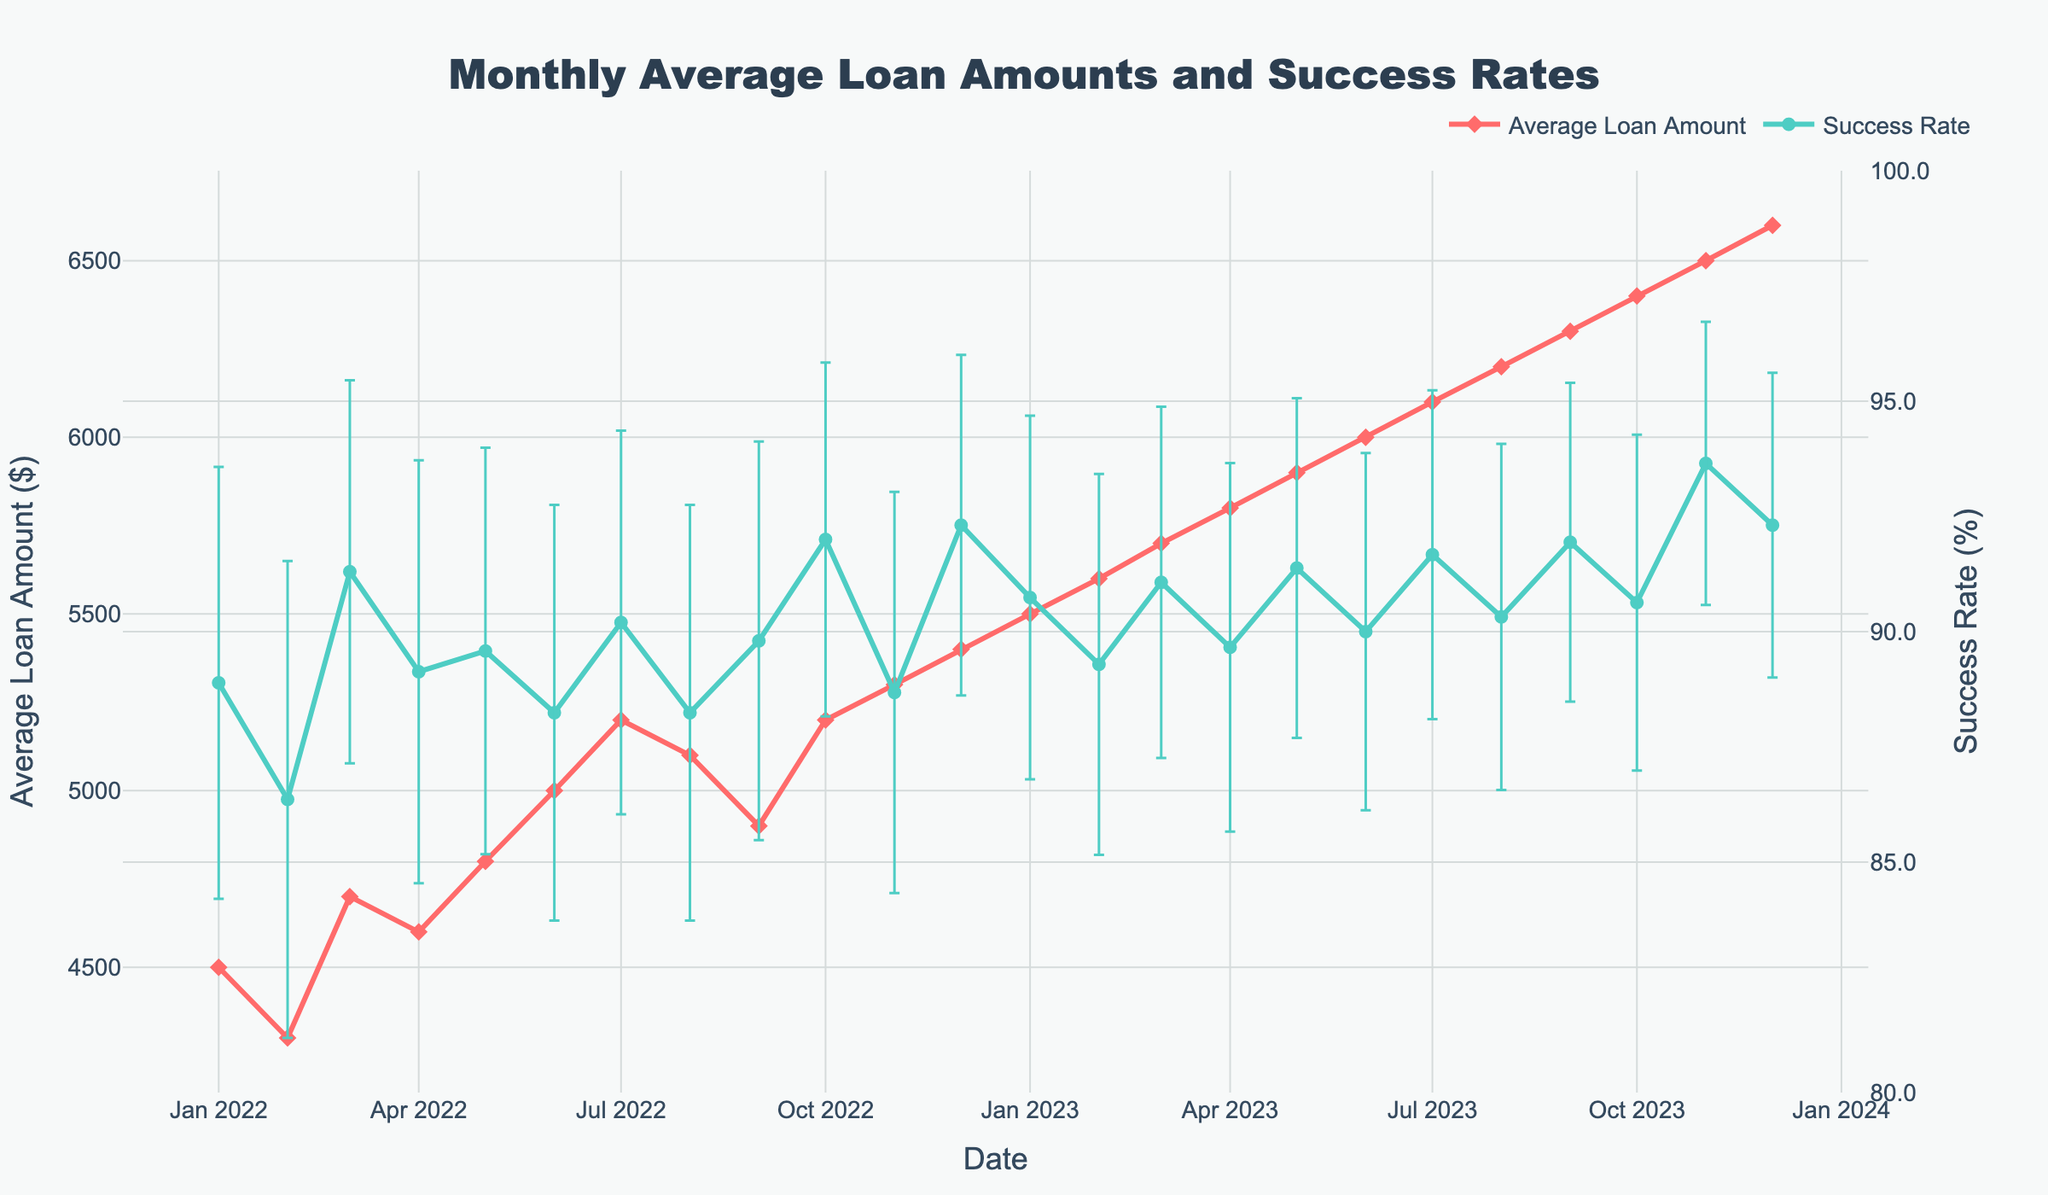What is the title of the figure? The title is displayed at the top center of the figure in large, bold text. It reads "Monthly Average Loan Amounts and Success Rates".
Answer: Monthly Average Loan Amounts and Success Rates How many data points are plotted for the average loan amount? To determine the number of data points, we need to count the markers on the "Average Loan Amount" line. Since each month over two years is represented, there are 24 points.
Answer: 24 Which month and year had the highest average loan amount? By looking at the peak of the "Average Loan Amount" line, we see that the highest point is in December 2023.
Answer: December 2023 How does the success rate trend change over the two years? The "Success Rate" line generally trends upwards over the two-year period, starting from around 88% to peaking at approximately 93% by the end.
Answer: Upwards In which month was the success rate the lowest, and what was the rate? The lowest point on the "Success Rate" line is around February 2022, where the success rate is approximately 86.36%.
Answer: February 2022, 86.36% What is the range (highest and lowest) of the average loan amount over the two years? To find the range, identify the highest and lowest points on the "Average Loan Amount" line. The highest is $6600 (December 2023) and the lowest is $4300 (February 2022). Thus, the range is $6600 - $4300 = $2300.
Answer: $2300 Is there a month where the success and default rates sum does not equal 100%? Examine the use of success and default rates. The rates sum to 100% each month, indicating that the success rate + default rate = 100% consistently.
Answer: No What is the margin of error for the success rate in November 2023? The error bars indicate the uncertainty. For November 2023, the success rate is 93.65%, with the error bars showing the range. The margin shown by these bars should approximately reflect the uncertainty due to sample size. It's roughly ±1%.
Answer: ±1% How does the average loan amount change from January 2022 to January 2023? Reviewing January 2022 and January 2023 on the "Average Loan Amount" line, the amount increases from $4500 to $5500. The change is $5500 - $4500 = $1000.
Answer: $1000 Is the success rate more consistent or the average loan amount across the two years? Assessing the fluctuations, the "Success Rate" line is relatively flatter compared to the more noticeable changes in the "Average Loan Amount" line. Thus, the success rate is more consistent.
Answer: Success rate 